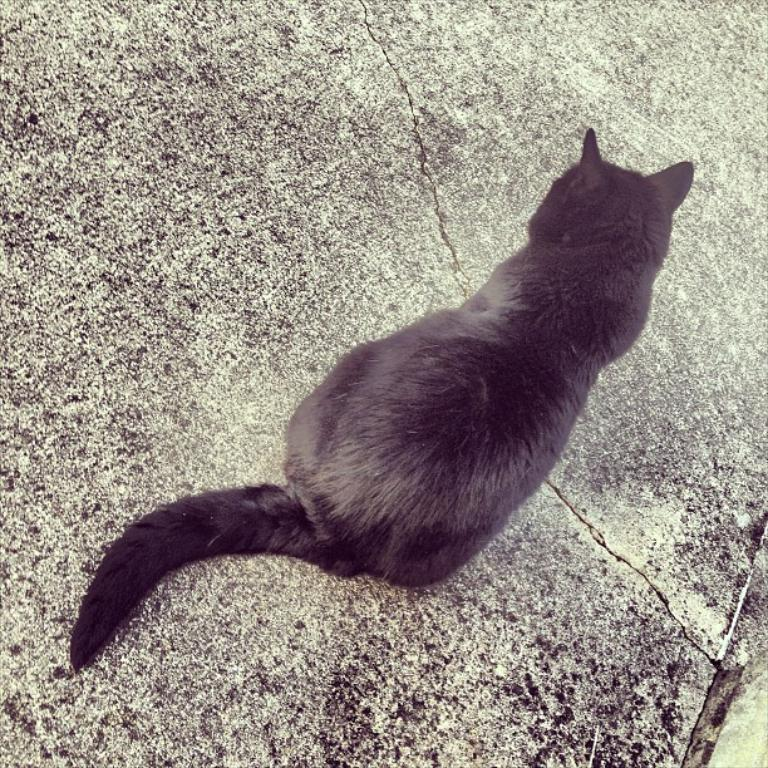What type of animal is in the image? The animal in the image is a cat. What color is the cat? The cat is in black and white color. Where is the cat located in the image? The cat is sitting on the floor. Can you describe the floor in the image? There is a crack on the floor. What type of hose is the cat using to water the plants in the image? There is no hose present in the image, and the cat is not watering any plants. 